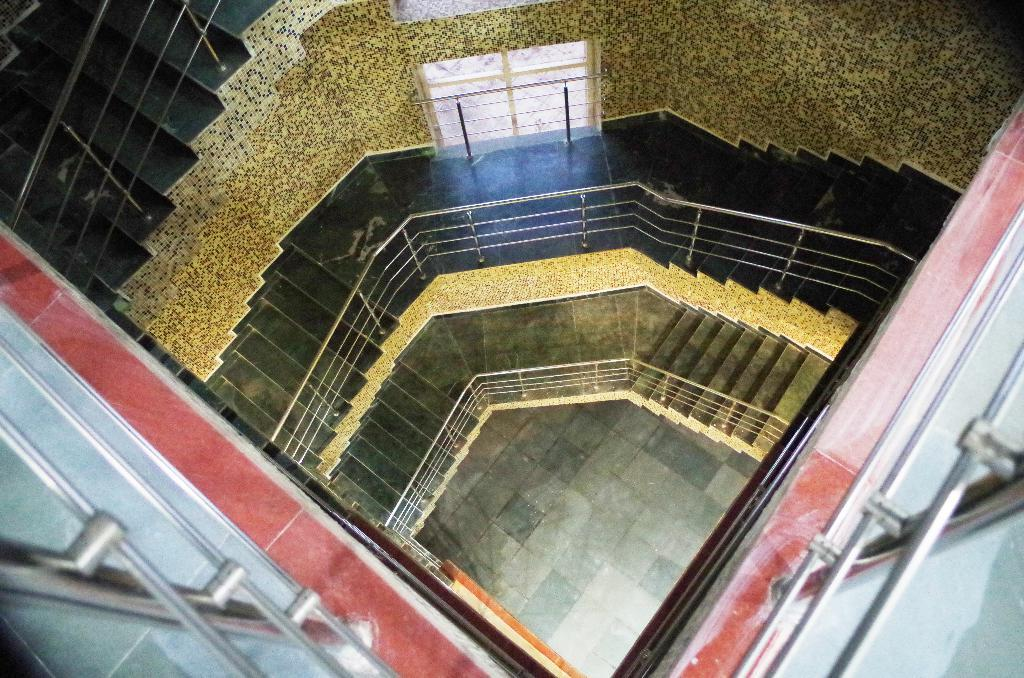What type of structures can be seen in the image? There are rods, fences, steps, walls, and a window visible in the image. What part of the image might be used for walking or climbing? The steps in the image might be used for walking or climbing. What is visible on the floor in the image? The floor is visible in the image. What type of yak can be seen grazing near the window in the image? There is no yak present in the image; it features structures such as rods, fences, steps, walls, and a window. What type of print is visible on the walls in the image? There is no print visible on the walls in the image; the walls are plain. 